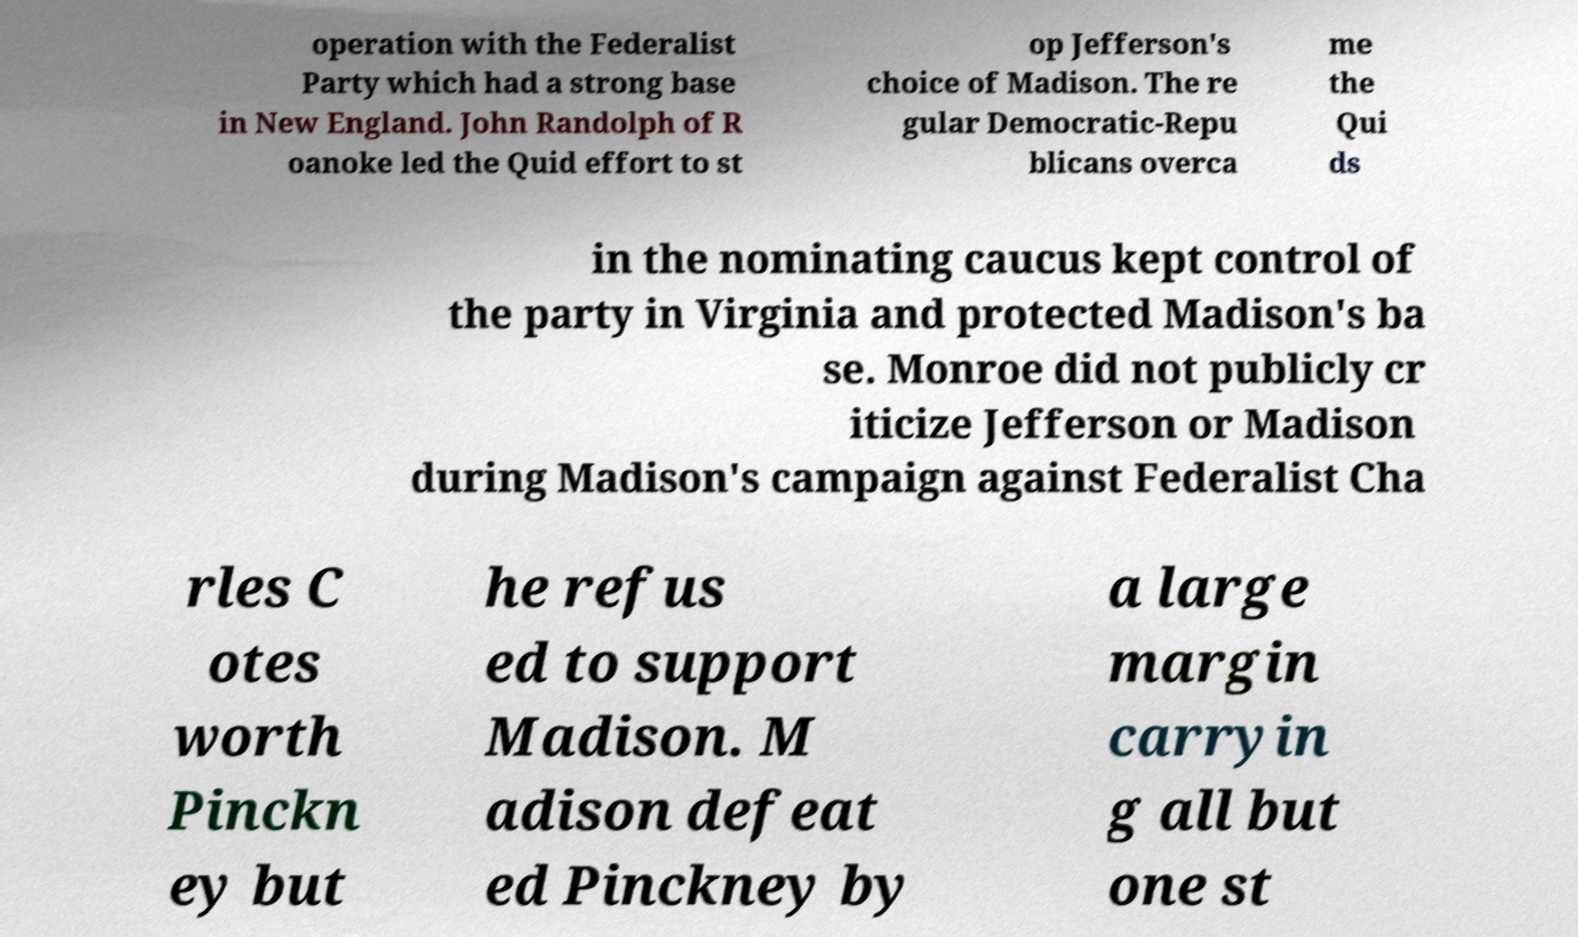What messages or text are displayed in this image? I need them in a readable, typed format. operation with the Federalist Party which had a strong base in New England. John Randolph of R oanoke led the Quid effort to st op Jefferson's choice of Madison. The re gular Democratic-Repu blicans overca me the Qui ds in the nominating caucus kept control of the party in Virginia and protected Madison's ba se. Monroe did not publicly cr iticize Jefferson or Madison during Madison's campaign against Federalist Cha rles C otes worth Pinckn ey but he refus ed to support Madison. M adison defeat ed Pinckney by a large margin carryin g all but one st 